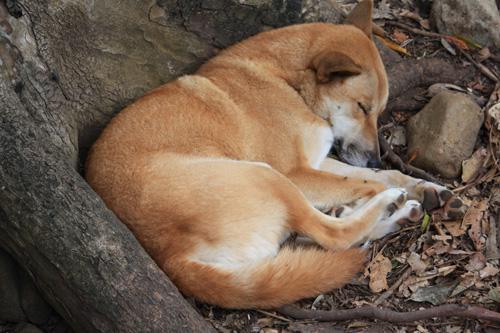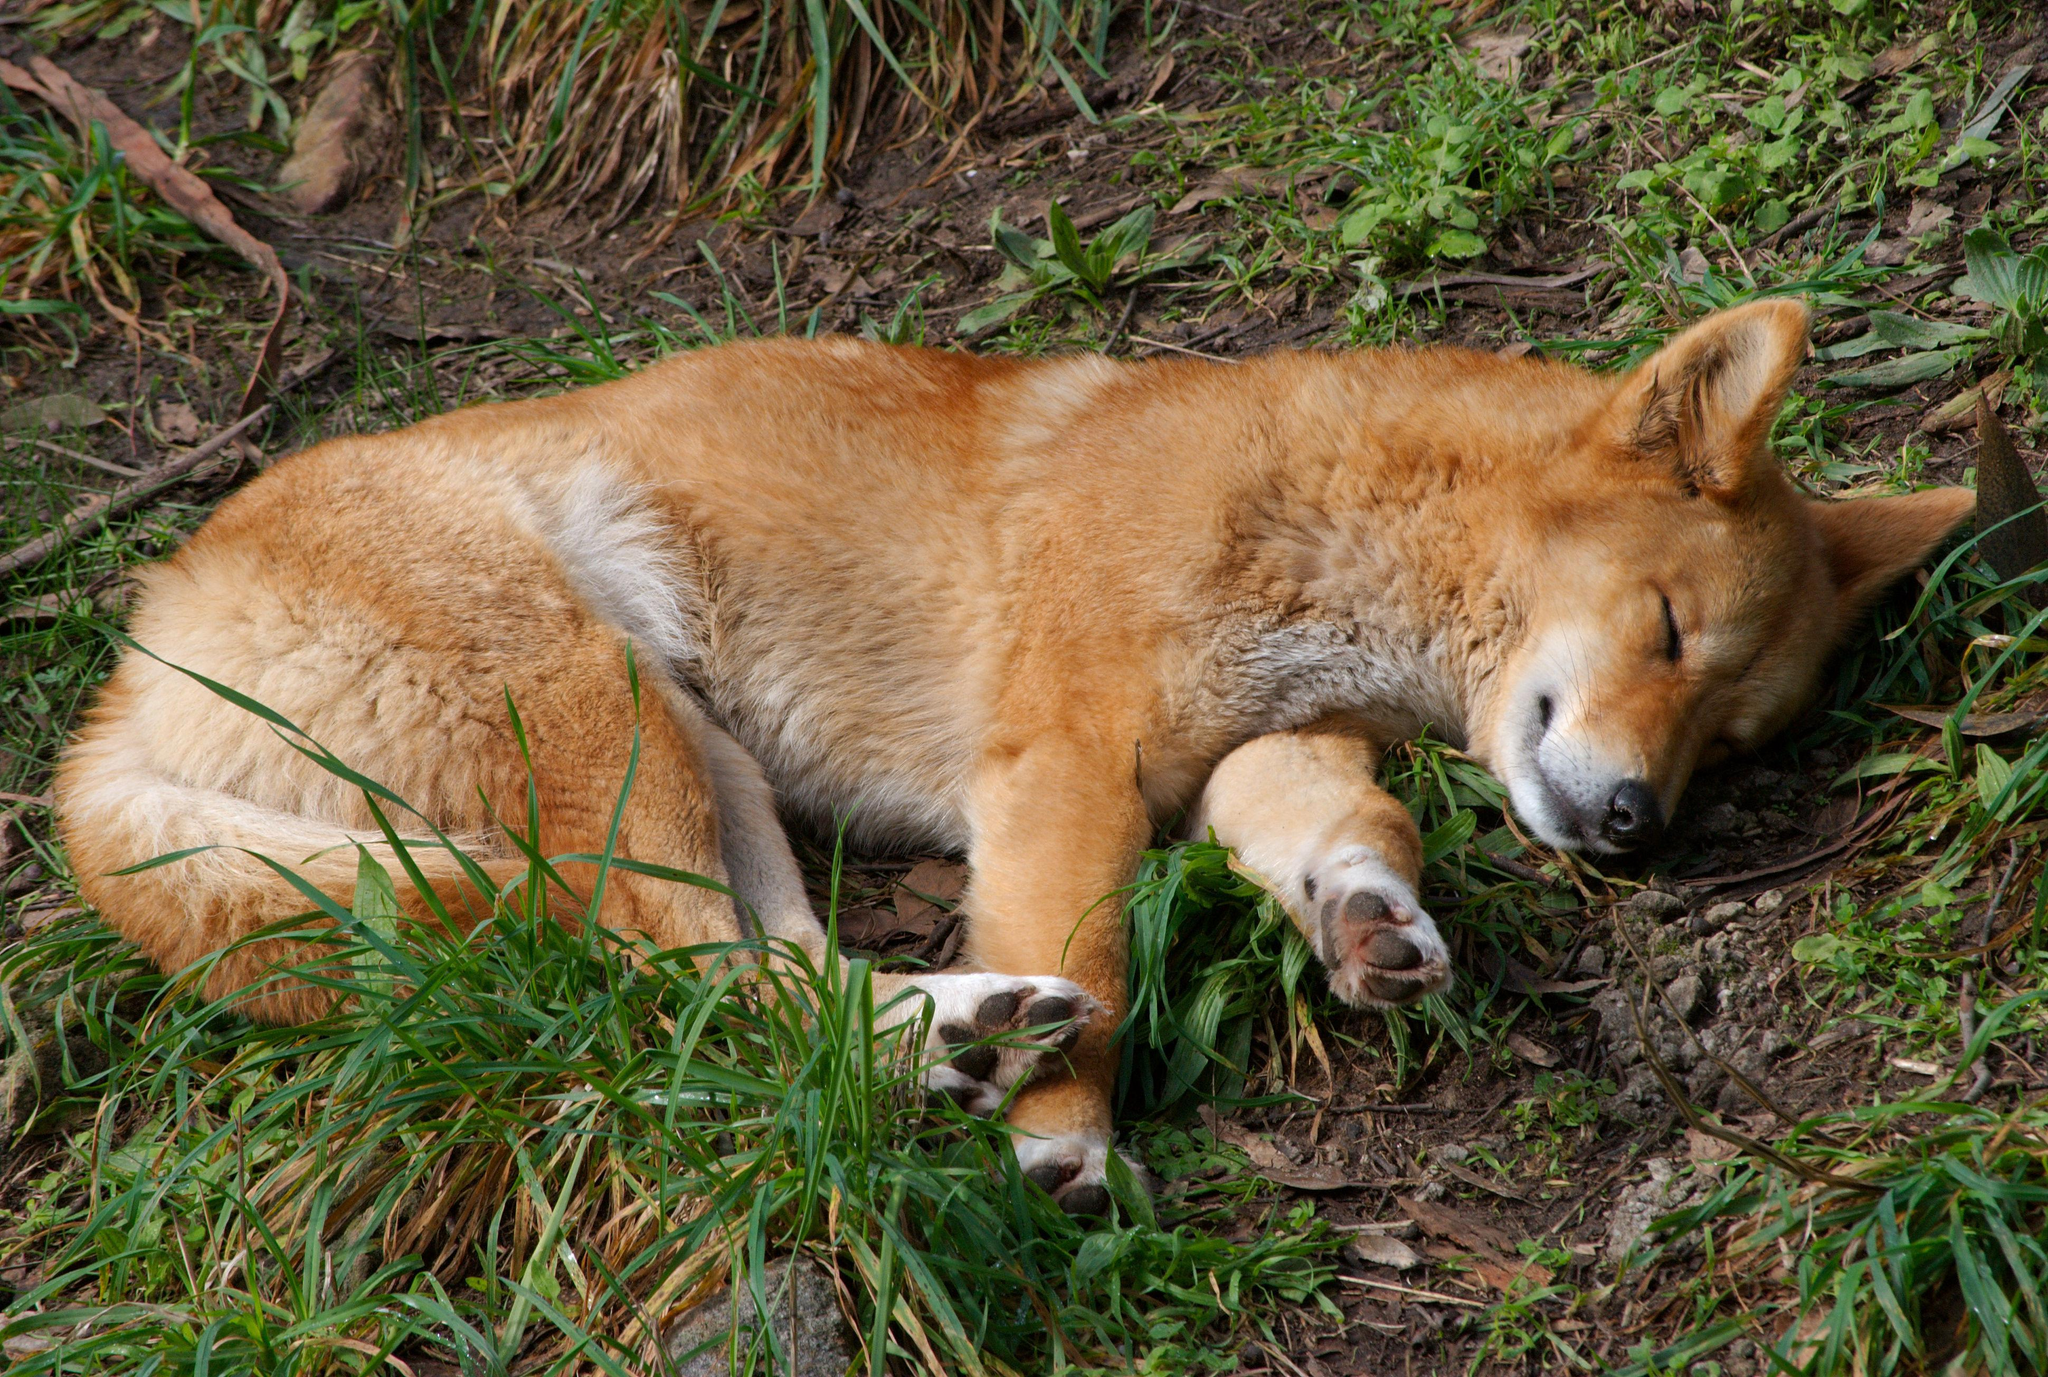The first image is the image on the left, the second image is the image on the right. For the images displayed, is the sentence "One of the images shows a dog laying near a tree." factually correct? Answer yes or no. Yes. The first image is the image on the left, the second image is the image on the right. For the images displayed, is the sentence "Each image shows one reclining orange dingo with its eyes closed and its head down instead of raised, and no dingos are tiny pups." factually correct? Answer yes or no. Yes. 